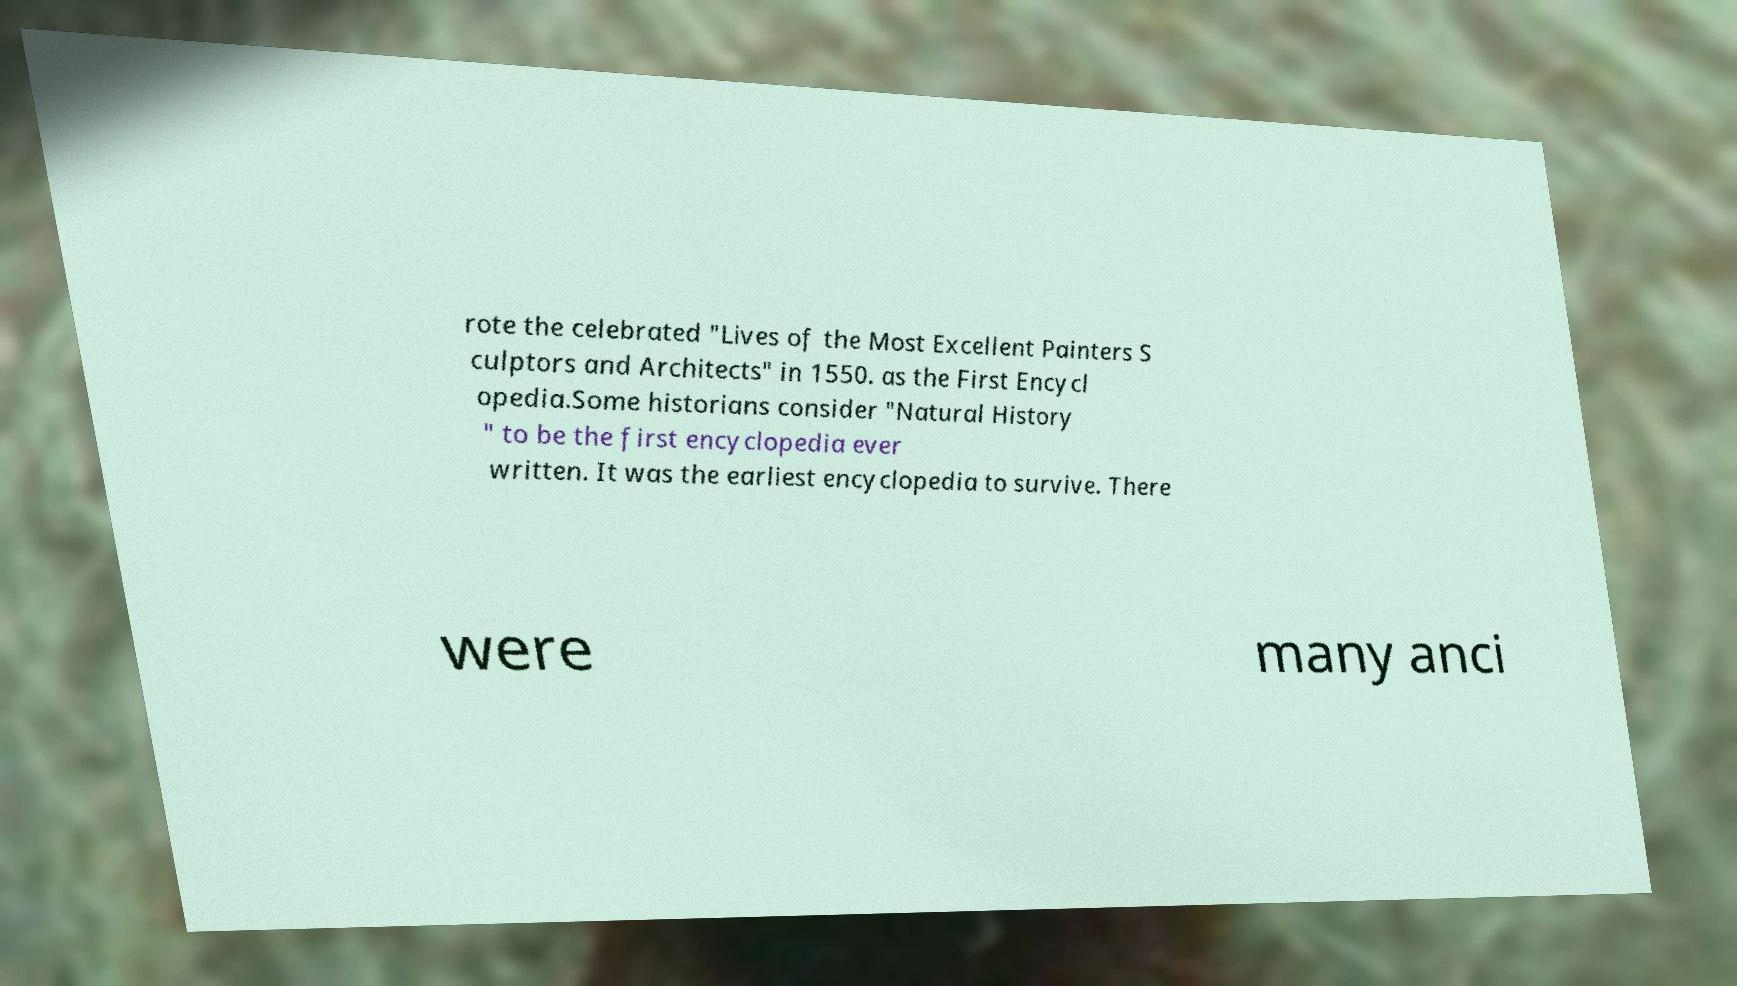Please read and relay the text visible in this image. What does it say? rote the celebrated "Lives of the Most Excellent Painters S culptors and Architects" in 1550. as the First Encycl opedia.Some historians consider "Natural History " to be the first encyclopedia ever written. It was the earliest encyclopedia to survive. There were many anci 